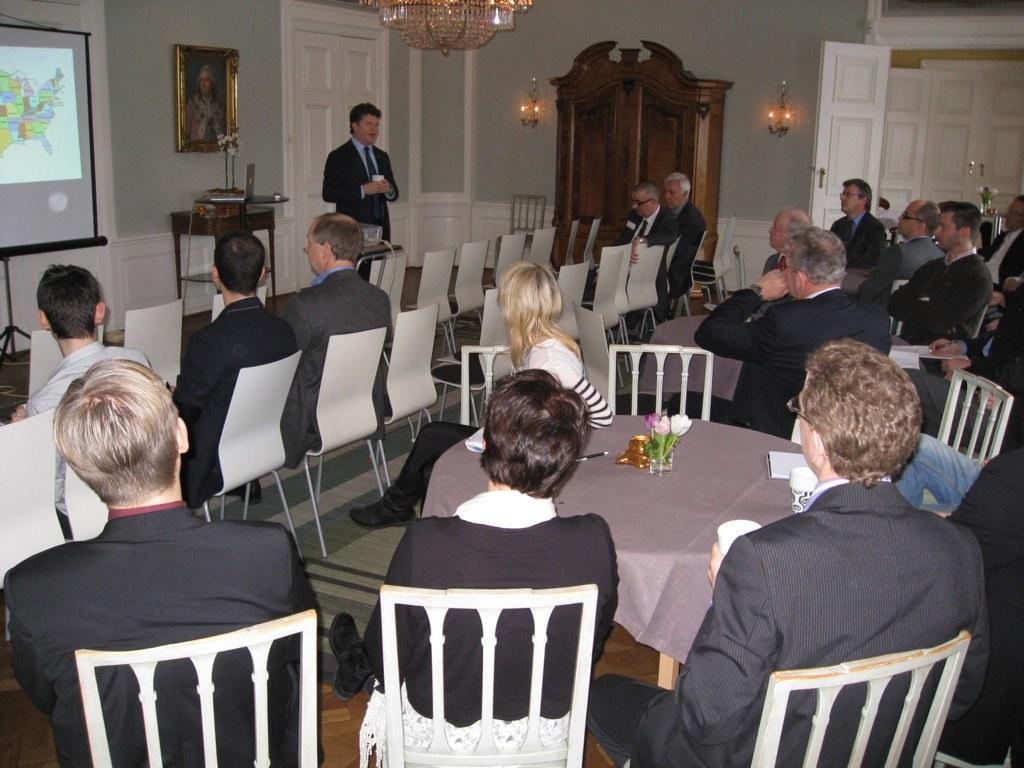How would you summarize this image in a sentence or two? In the image we can see there are people who are sitting on chair and there is a person who is standing. 